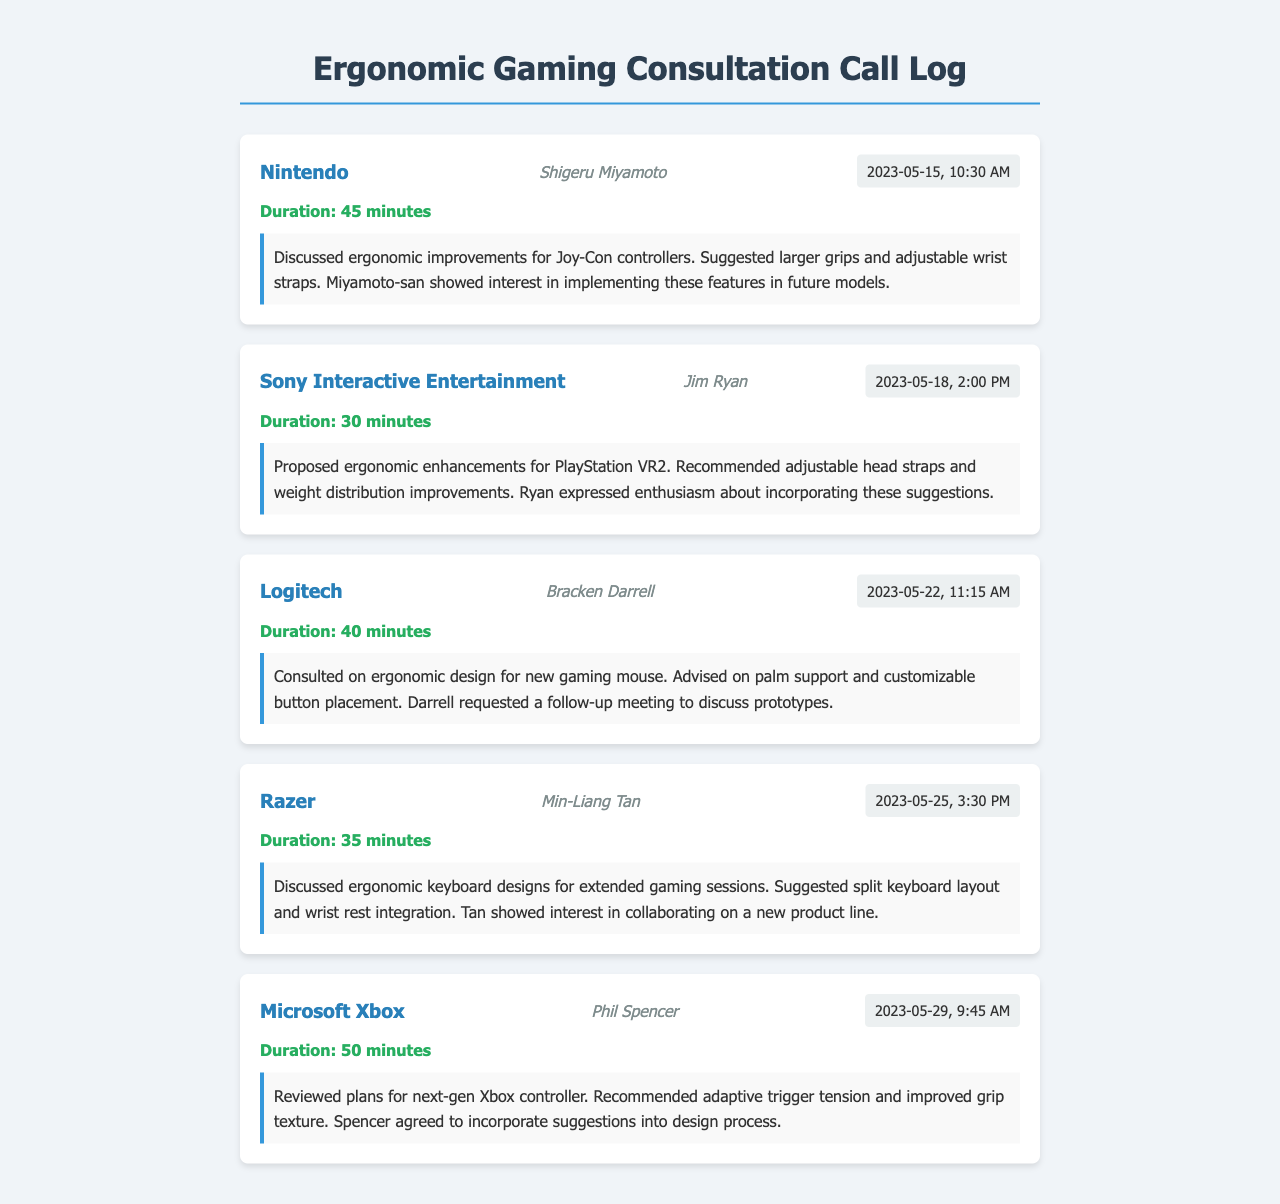What was the duration of the call with Nintendo? The call log states that the duration of the call with Nintendo is 45 minutes.
Answer: 45 minutes Who was the contact for the call with Sony Interactive Entertainment? The document lists Jim Ryan as the contact person for Sony Interactive Entertainment.
Answer: Jim Ryan What ergonomic feature was suggested for the PlayStation VR2? The notes mention that adjustable head straps were recommended for the PlayStation VR2.
Answer: Adjustable head straps Which company showed interest in collaborating on a new product line? The call with Razer indicates that Min-Liang Tan showed interest in collaborating on a new product line.
Answer: Razer How many minutes was the consultation with Microsoft Xbox? The document indicates that the consultation with Microsoft Xbox lasted for 50 minutes.
Answer: 50 minutes What adjustment was proposed for the Joy-Con controllers? The consultation notes suggest that larger grips were proposed for the Joy-Con controllers.
Answer: Larger grips On what date did the call with Logitech occur? The call log states that the consultation with Logitech took place on May 22, 2023.
Answer: May 22, 2023 Which feature was recommended for the new gaming mouse? The notes mention palm support as a recommended feature for the new gaming mouse.
Answer: Palm support What was discussed regarding the next-gen Xbox controller? The notes indicate that improvements to grip texture were discussed for the next-gen Xbox controller.
Answer: Improved grip texture 